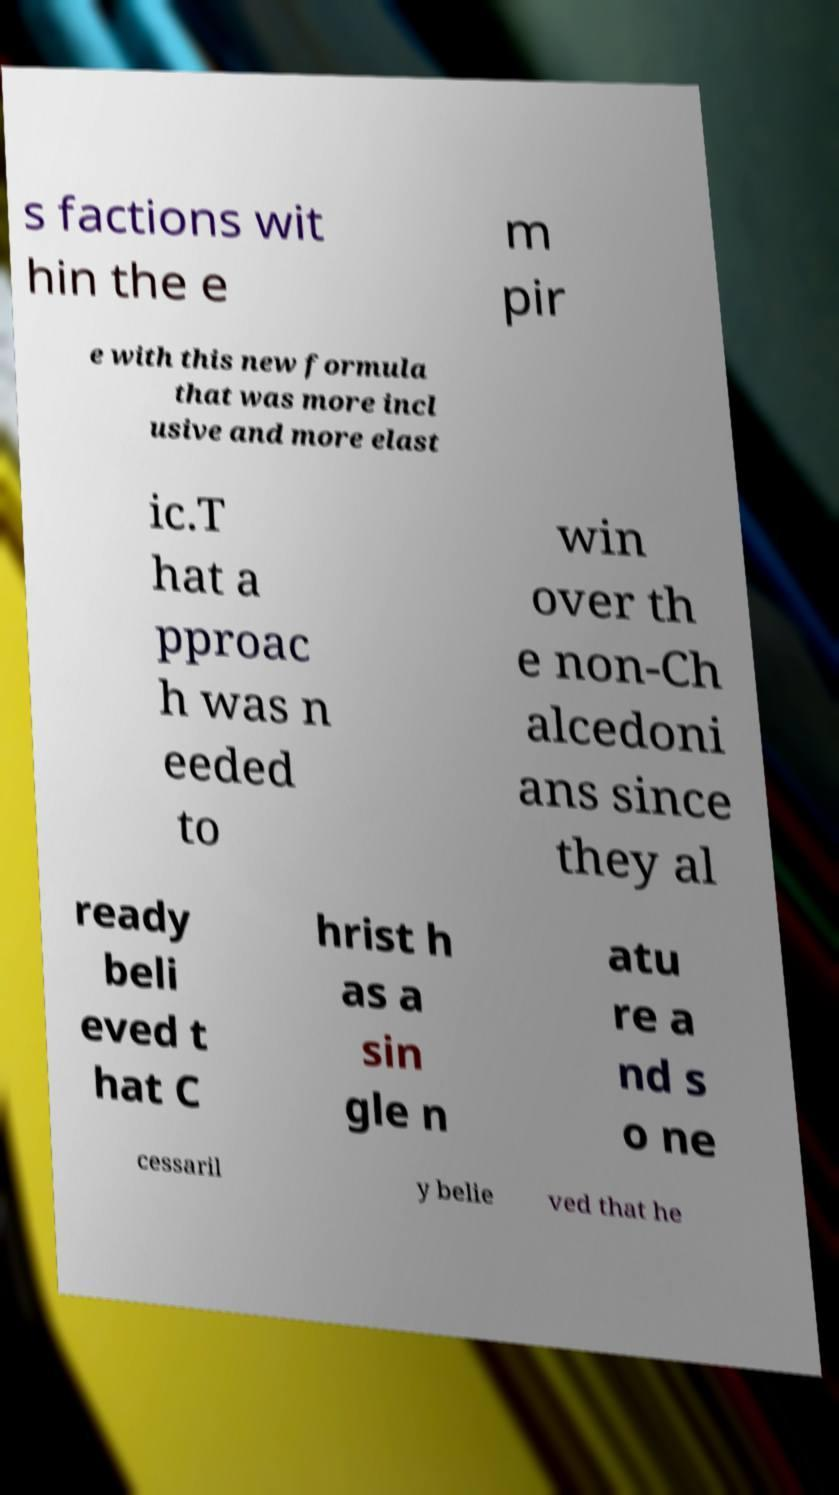I need the written content from this picture converted into text. Can you do that? s factions wit hin the e m pir e with this new formula that was more incl usive and more elast ic.T hat a pproac h was n eeded to win over th e non-Ch alcedoni ans since they al ready beli eved t hat C hrist h as a sin gle n atu re a nd s o ne cessaril y belie ved that he 